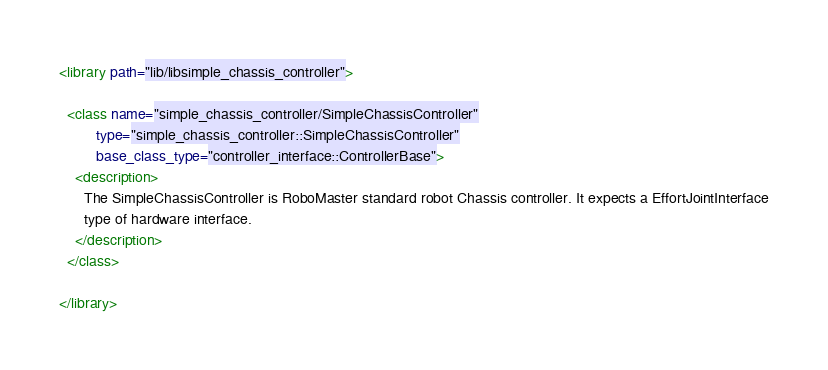Convert code to text. <code><loc_0><loc_0><loc_500><loc_500><_XML_><library path="lib/libsimple_chassis_controller">

  <class name="simple_chassis_controller/SimpleChassisController"
         type="simple_chassis_controller::SimpleChassisController"
         base_class_type="controller_interface::ControllerBase">
    <description>
      The SimpleChassisController is RoboMaster standard robot Chassis controller. It expects a EffortJointInterface
      type of hardware interface.
    </description>
  </class>

</library>
</code> 